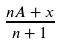Convert formula to latex. <formula><loc_0><loc_0><loc_500><loc_500>\frac { n A + x } { n + 1 }</formula> 